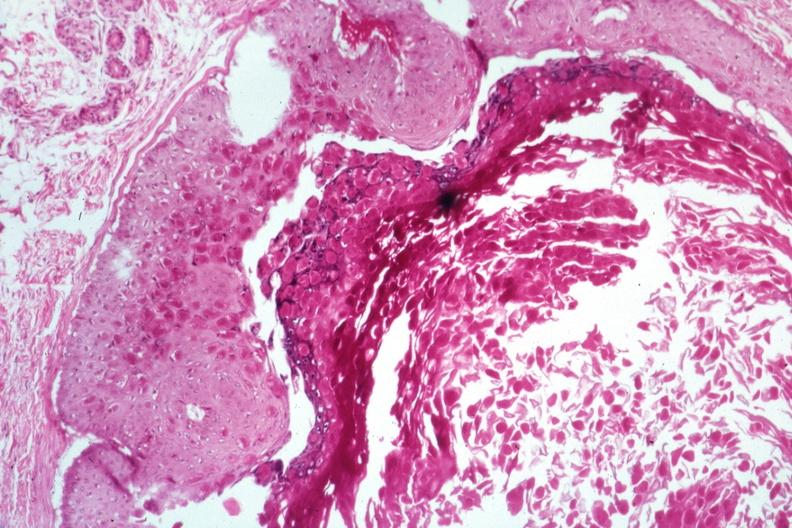what does this image show?
Answer the question using a single word or phrase. Large inclusion bodies well shown 